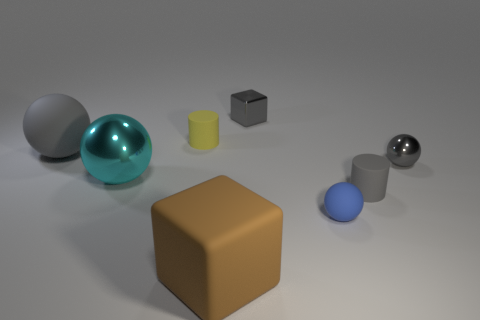What is the size of the gray block that is the same material as the cyan object?
Keep it short and to the point. Small. What color is the small sphere that is made of the same material as the small gray cylinder?
Your answer should be very brief. Blue. Are there any yellow rubber cylinders that have the same size as the gray cube?
Make the answer very short. Yes. There is a small gray object that is the same shape as the large metallic object; what material is it?
Offer a terse response. Metal. There is a yellow thing that is the same size as the gray matte cylinder; what shape is it?
Provide a succinct answer. Cylinder. Are there any other tiny metallic objects that have the same shape as the brown object?
Offer a very short reply. Yes. What is the shape of the metal object that is to the right of the small ball that is to the left of the gray matte cylinder?
Offer a terse response. Sphere. What is the shape of the large brown rubber thing?
Ensure brevity in your answer.  Cube. There is a blue sphere behind the big rubber object that is right of the metal sphere to the left of the gray shiny block; what is it made of?
Offer a terse response. Rubber. How many other things are the same material as the blue object?
Provide a short and direct response. 4. 